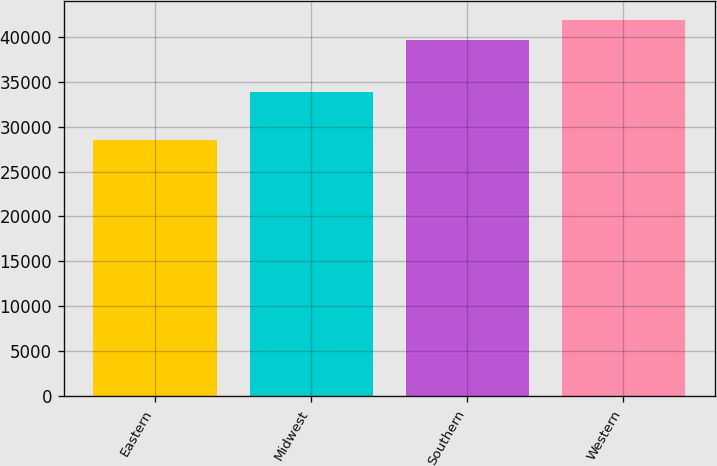Convert chart. <chart><loc_0><loc_0><loc_500><loc_500><bar_chart><fcel>Eastern<fcel>Midwest<fcel>Southern<fcel>Western<nl><fcel>28509<fcel>33829<fcel>39622<fcel>41870<nl></chart> 